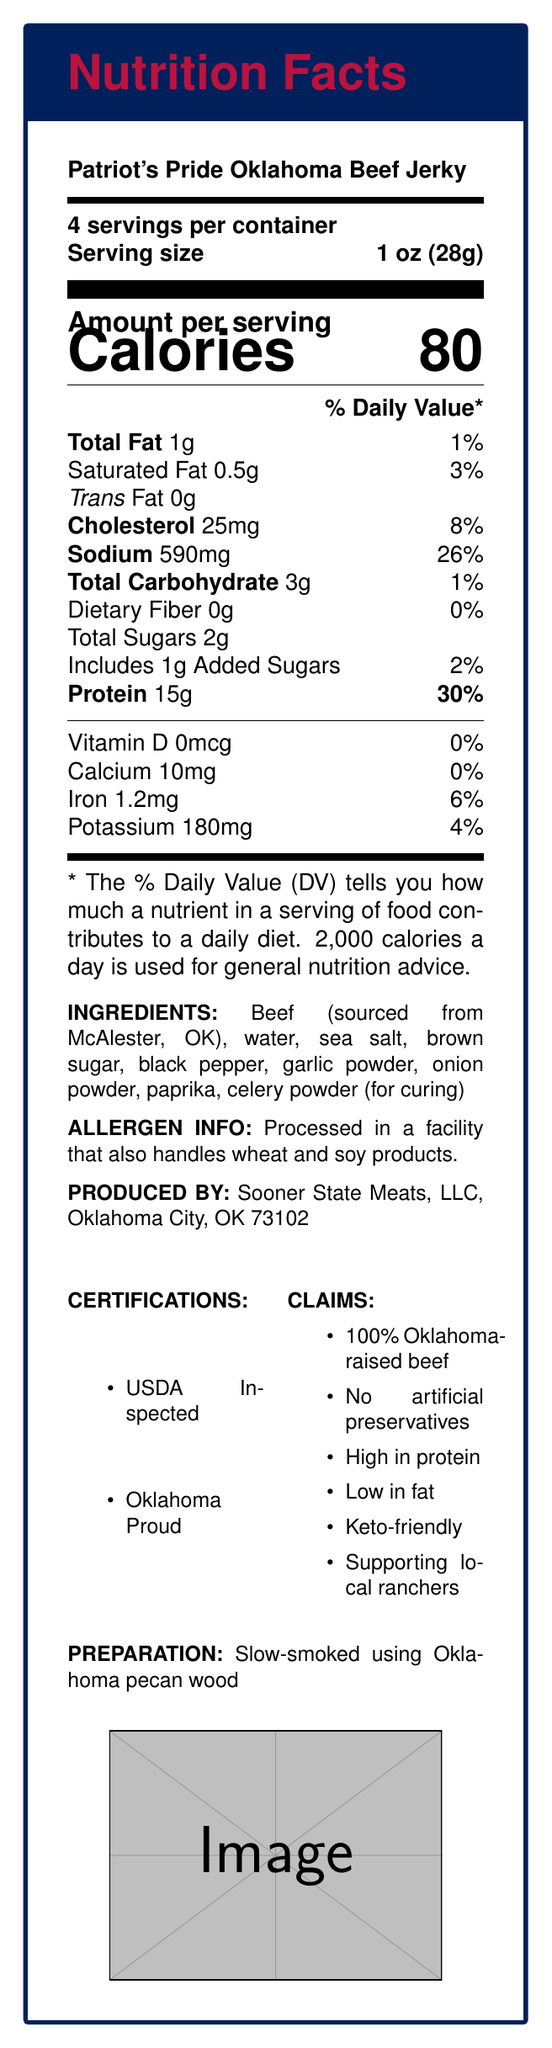what is the serving size? The document lists the serving size as 1 oz (28g).
Answer: 1 oz (28g) how many servings are there per container? The document states there are 4 servings per container.
Answer: 4 how many grams of protein are in one serving? The document states there are 15 grams of protein per serving.
Answer: 15g what percentage of the daily value of protein does one serving provide? The document indicates that one serving provides 30% of the daily value for protein.
Answer: 30% how many calories are there per serving? The document states there are 80 calories per serving.
Answer: 80 how much saturated fat is there in one serving? The document states there is 0.5 grams of saturated fat per serving.
Answer: 0.5g are there any artificial preservatives in this beef jerky? The marketing claims in the document state there are no artificial preservatives.
Answer: No how much sodium is in one serving of this beef jerky? A. 500mg B. 560mg C. 590mg D. 620mg The document lists the sodium content as 590mg per serving.
Answer: C. 590mg what is the daily value percentage of cholesterol for one serving? A. 6% B. 8% C. 10% D. 12% The document shows the daily value percentage of cholesterol as 8%.
Answer: B. 8% is this product gluten-free? The allergen information states it is processed in a facility that handles wheat, so it cannot be confirmed as gluten-free.
Answer: No what are the certifications listed in the document? The document lists the certifications as USDA Inspected and Oklahoma Proud.
Answer: USDA Inspected, Oklahoma Proud describe the preparation method of this beef jerky. The document states the beef jerky is slow-smoked using Oklahoma pecan wood.
Answer: Slow-smoked using Oklahoma pecan wood does this beef jerky contain any dietary fiber? The document lists the dietary fiber content as 0g, indicating it does not contain any dietary fiber.
Answer: No what are some marketing claims made about this beef jerky? The marketing claims listed in the document include 100% Oklahoma-raised beef, No artificial preservatives, High in protein, Low in fat, Keto-friendly, Supporting local ranchers.
Answer: 100% Oklahoma-raised beef, No artificial preservatives, High in protein, Low in fat, Keto-friendly, Supporting local ranchers what is the calcium weight in one serving? The document states there are 10 milligrams of calcium per serving.
Answer: 10mg summarize the main idea of the document. The document gives a detailed view of the nutritional content and other characteristics of Patriot's Pride Oklahoma Beef Jerky, emphasizing its high protein content and local Oklahoma sourcing.
Answer: The document provides the nutrition facts for Patriot's Pride Oklahoma Beef Jerky, highlighting its high protein content with 15 grams per serving. It specifies the serving size, calories, and detailed nutrient breakdown, along with ingredients, allergen info, certifications, marketing claims, and the preparation method. where does the beef used in this product come from? The document lists McAlester, OK as the source of the beef used in the jerky.
Answer: McAlester, OK what's the added sugars content in one serving? The document specifies that there is 1 gram of added sugars per serving.
Answer: 1g what is the total carbohydrate content per serving? The document states there are 3 grams of total carbohydrate per serving.
Answer: 3g how long has this product been on the market? The document does not provide any information on the duration this product has been on the market.
Answer: Not enough information 